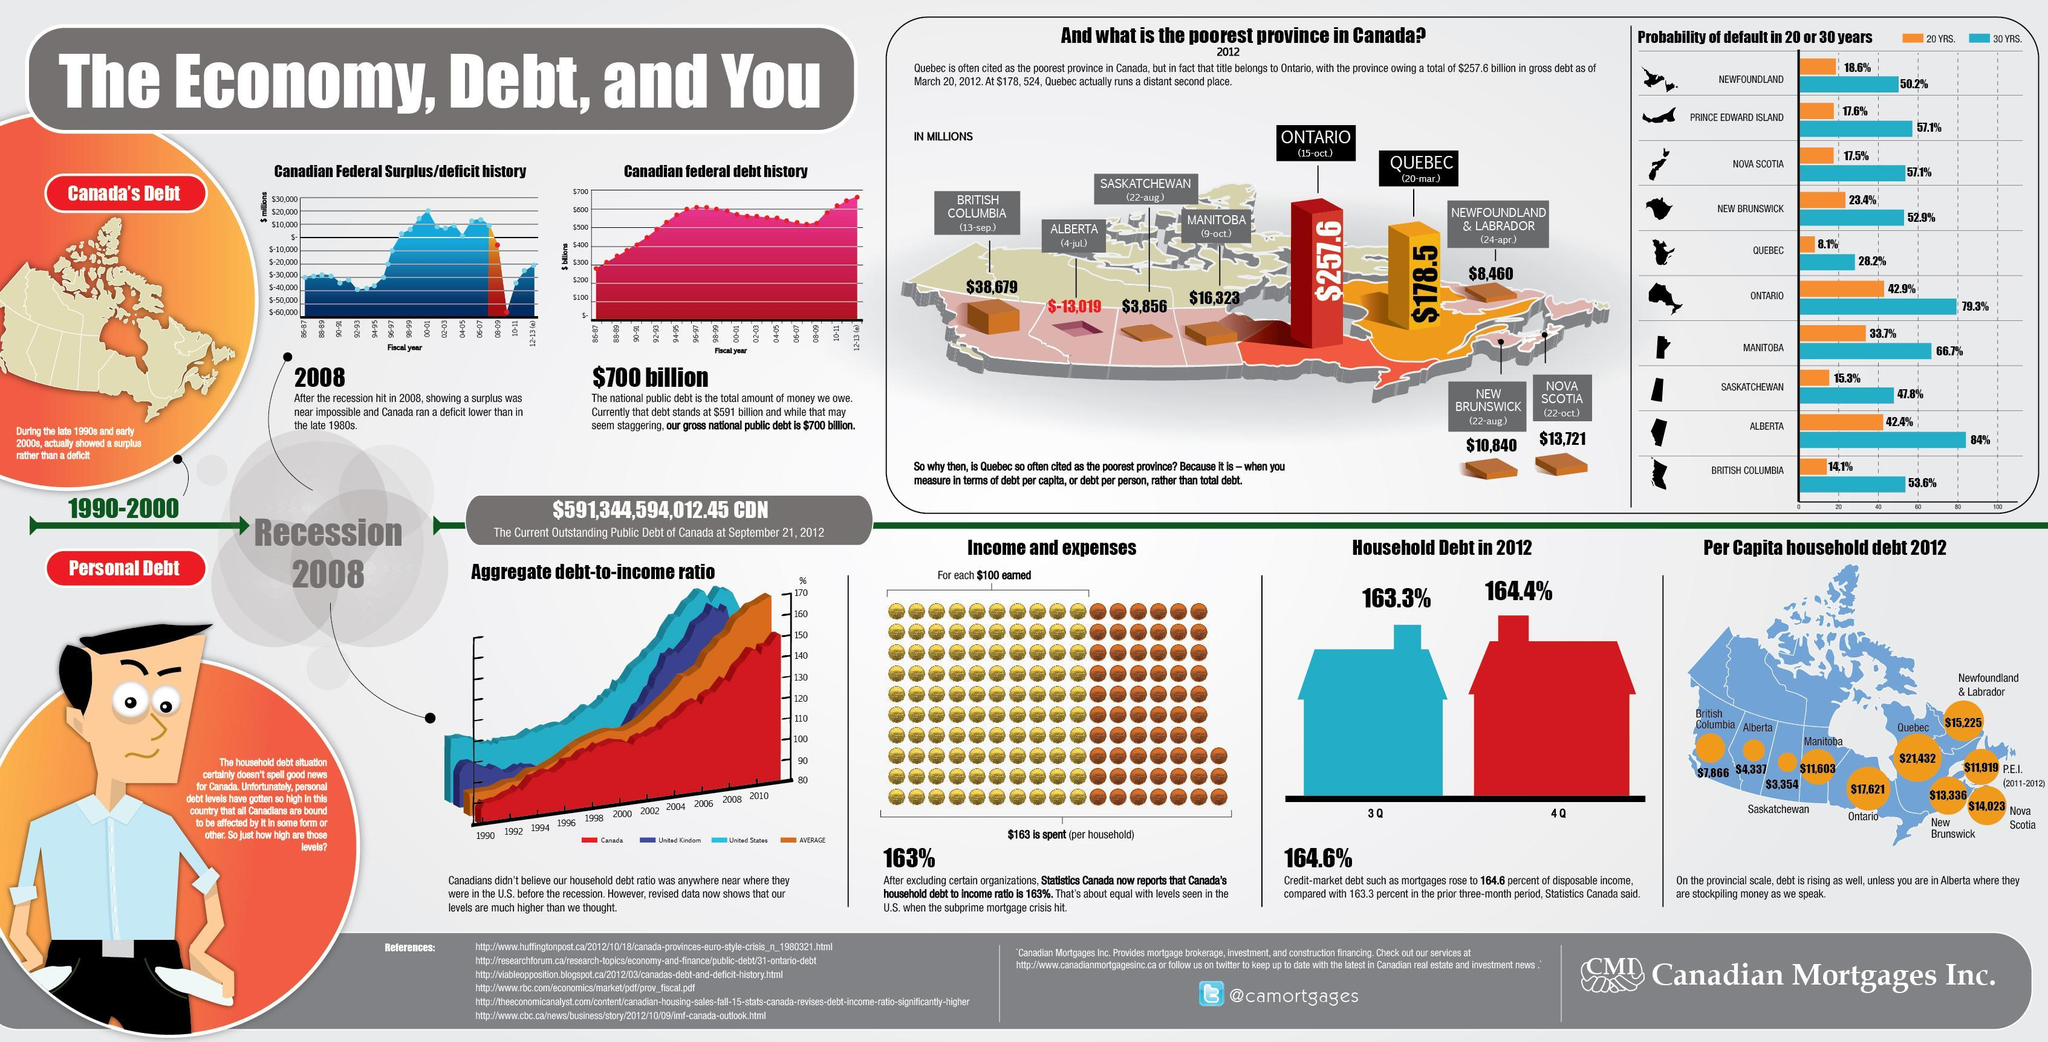Which province in Canada has the least per capita household debt in 2012?
Answer the question with a short phrase. Alberta What is the probability of default of Alberta in 30 years? 84% What is the probability of default of Nova Scotia in 20 years? 17.5% What is the per capita household debt in Ontario in 2012? $17,621 Which province in Canada has the highest per capita household debt in 2012? Quebec What is the probability of default of Ontario in 30 years? 79.3% Which province in Canada has the second highest per capita household debt in 2012? Newfoundland & Labrador What is the per capita household debt in Alberta in 2012? $4,337 